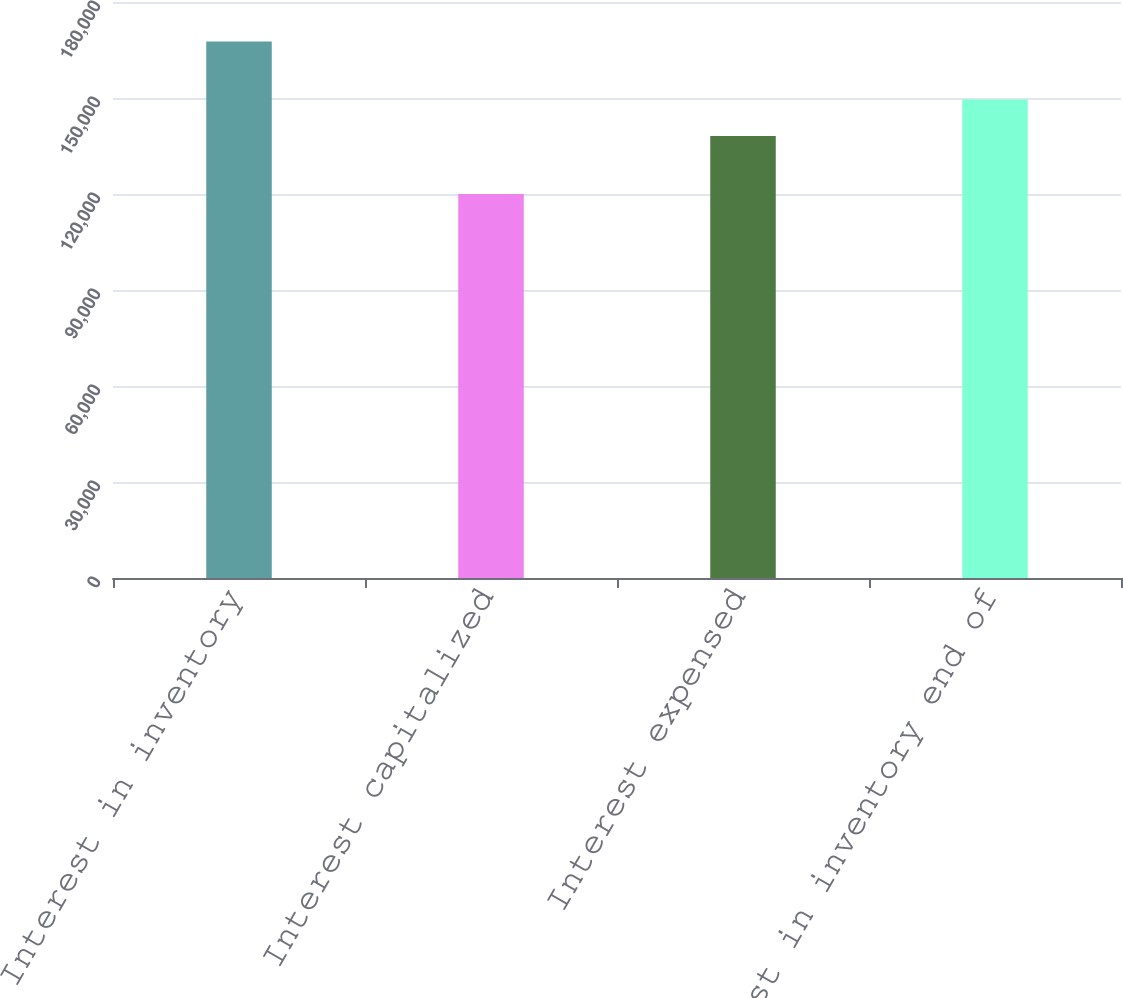<chart> <loc_0><loc_0><loc_500><loc_500><bar_chart><fcel>Interest in inventory<fcel>Interest capitalized<fcel>Interest expensed<fcel>Interest in inventory end of<nl><fcel>167638<fcel>120001<fcel>138141<fcel>149498<nl></chart> 